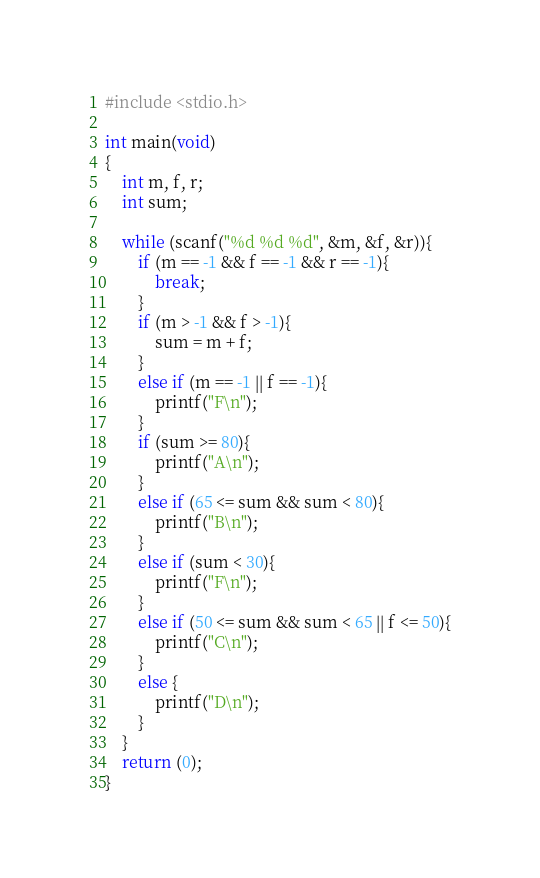<code> <loc_0><loc_0><loc_500><loc_500><_C_>#include <stdio.h>

int main(void)
{
	int m, f, r;
	int sum;
	
	while (scanf("%d %d %d", &m, &f, &r)){
		if (m == -1 && f == -1 && r == -1){
			break;
		}
		if (m > -1 && f > -1){
			sum = m + f;
		}
		else if (m == -1 || f == -1){
			printf("F\n");
		}
		if (sum >= 80){
			printf("A\n");
		}
		else if (65 <= sum && sum < 80){
			printf("B\n");
		}
		else if (sum < 30){
			printf("F\n");
		}
		else if (50 <= sum && sum < 65 || f <= 50){
			printf("C\n");
		}
		else {
			printf("D\n");
		}
	}
	return (0);
}</code> 